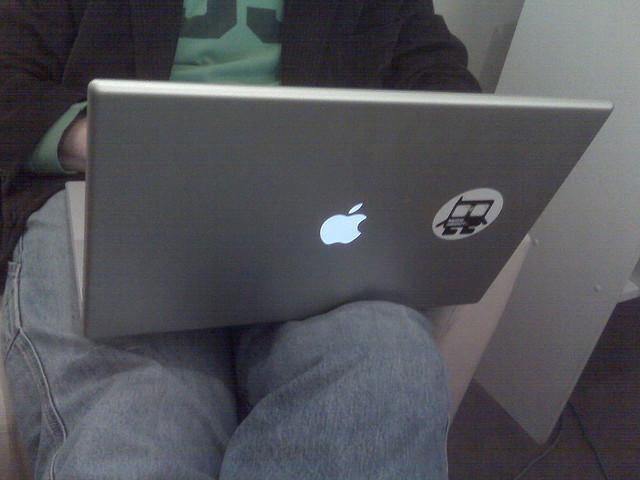What is the word on the lid of the laptop?
Concise answer only. None. What color is the laptop?
Concise answer only. Gray. What work is repeated in the sticker on the computer?
Write a very short answer. Apple. What logo is on the white laptop?
Answer briefly. Apple. What words are on the computer?
Concise answer only. 0. What brand is the laptop?
Concise answer only. Apple. What print is on this person's pants?
Concise answer only. Solid. Is the person standing?
Quick response, please. No. What color are the pants?
Short answer required. Blue. 